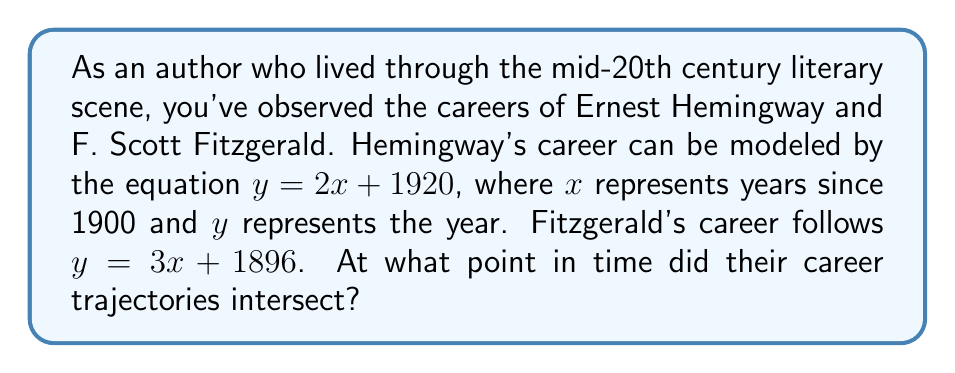Can you solve this math problem? To find the intersection point of these two authors' career trajectories, we need to solve the system of linear equations:

$$\begin{cases}
y = 2x + 1920 \quad \text{(Hemingway)}\\
y = 3x + 1896 \quad \text{(Fitzgerald)}
\end{cases}$$

1) At the intersection point, the $y$ values are equal, so we can set the equations equal to each other:

   $2x + 1920 = 3x + 1896$

2) Subtract $2x$ from both sides:

   $1920 = x + 1896$

3) Subtract 1896 from both sides:

   $24 = x$

4) Now that we know $x$, we can substitute it into either of the original equations to find $y$. Let's use Hemingway's equation:

   $y = 2(24) + 1920 = 48 + 1920 = 1968$

5) Remember that $x$ represents years since 1900, so we need to add 1900 to get the actual year:

   $1900 + 24 = 1924$

Therefore, the career trajectories intersected in 1924.
Answer: 1924 